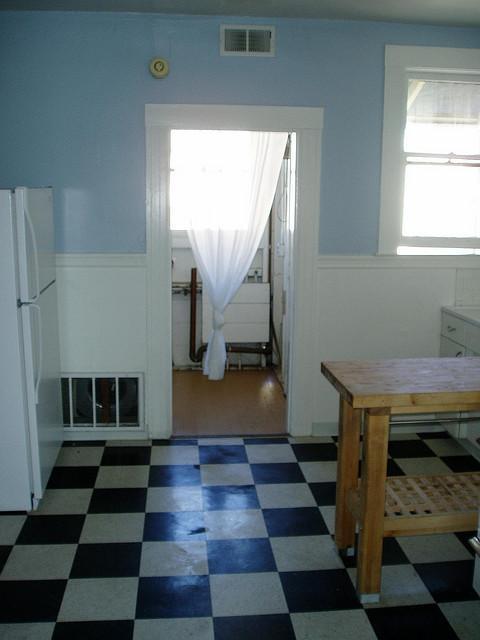How many stars are on the wall?
Give a very brief answer. 0. 